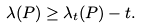Convert formula to latex. <formula><loc_0><loc_0><loc_500><loc_500>\lambda ( P ) \geq \lambda _ { t } ( P ) - t .</formula> 